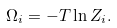<formula> <loc_0><loc_0><loc_500><loc_500>\Omega _ { i } = - T \ln Z _ { i } .</formula> 